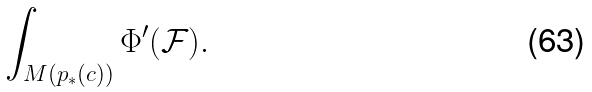Convert formula to latex. <formula><loc_0><loc_0><loc_500><loc_500>\int _ { M ( p _ { * } ( c ) ) } \Phi ^ { \prime } ( \mathcal { F } ) .</formula> 